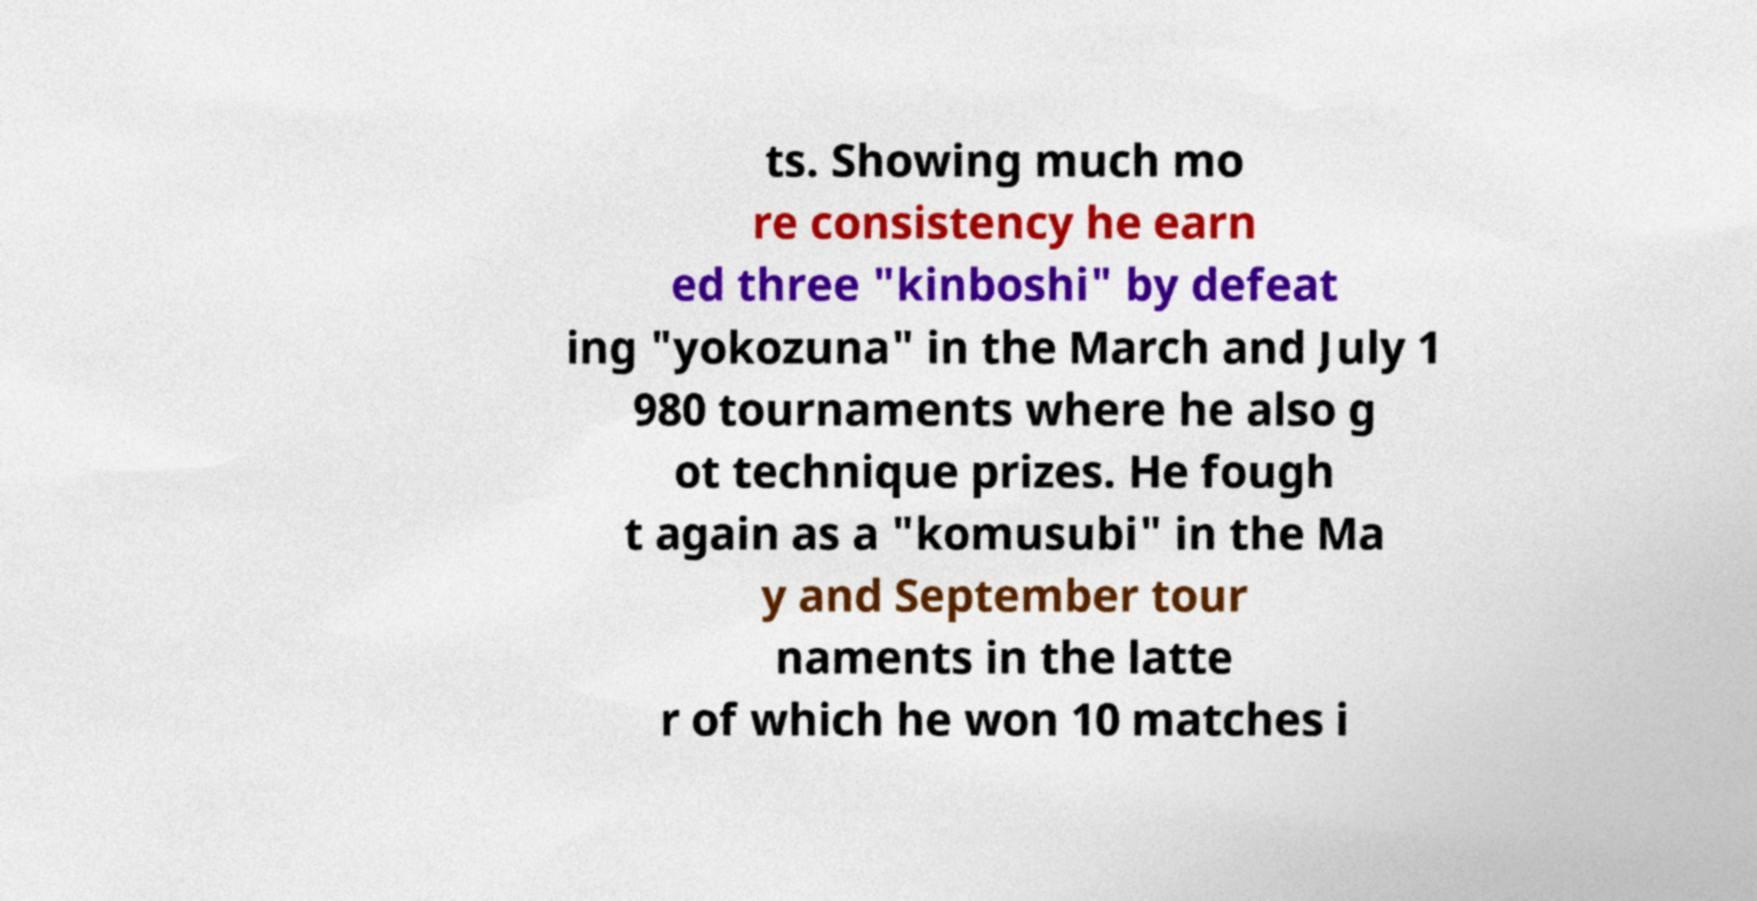I need the written content from this picture converted into text. Can you do that? ts. Showing much mo re consistency he earn ed three "kinboshi" by defeat ing "yokozuna" in the March and July 1 980 tournaments where he also g ot technique prizes. He fough t again as a "komusubi" in the Ma y and September tour naments in the latte r of which he won 10 matches i 